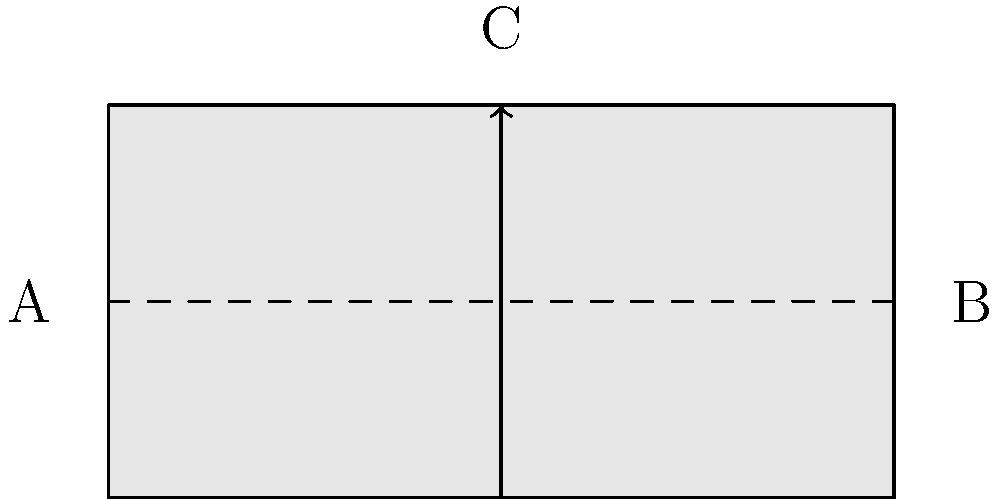In the context of plant morphology, consider a Möbius strip representation of a leaf structure. If a botanical specimen traverses the path from point A to point B along the dashed line, and then moves vertically to point C, what would be the orientation of the specimen relative to its starting position? To understand this problem, let's follow the path step-by-step:

1. The Möbius strip is a non-orientable surface, meaning it has only one side and one edge.

2. Starting at point A, the specimen moves along the dashed line to point B. On a Möbius strip, this motion alone doesn't change the orientation.

3. However, when the specimen moves vertically from B to C, it crosses the edge of the Möbius strip.

4. Crossing the edge of a Möbius strip causes a flip in orientation.

5. This flip means that what was previously the "top" of the specimen is now the "bottom," and vice versa.

6. In botanical terms, this could be analogous to the adaxial (upper) surface of a leaf becoming the abaxial (lower) surface.

Therefore, when the specimen reaches point C, its orientation will be inverted compared to its starting position at point A.
Answer: Inverted orientation 